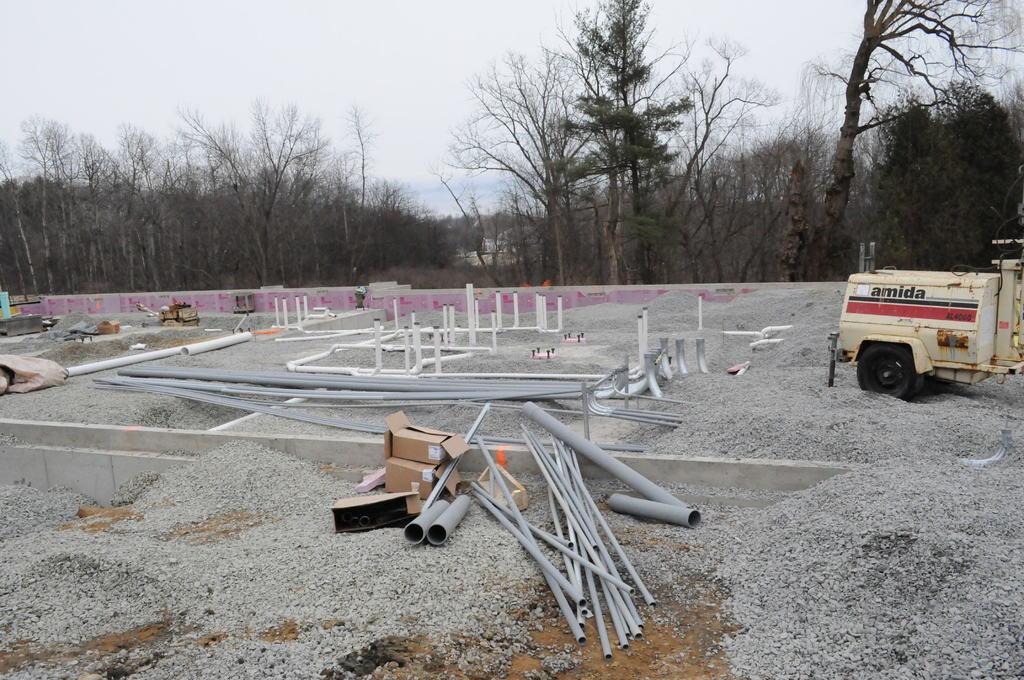In one or two sentences, can you explain what this image depicts? Here in this picture we can see heaps of gravel present on the ground and we can also see plastic pipes and card board boxes also present and on the right side we can see a machinery present and in the far we can see plants and trees present on the ground and we can also see the sky is cloudy. 